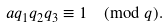<formula> <loc_0><loc_0><loc_500><loc_500>a q _ { 1 } q _ { 2 } q _ { 3 } \equiv 1 \pmod { q } .</formula> 